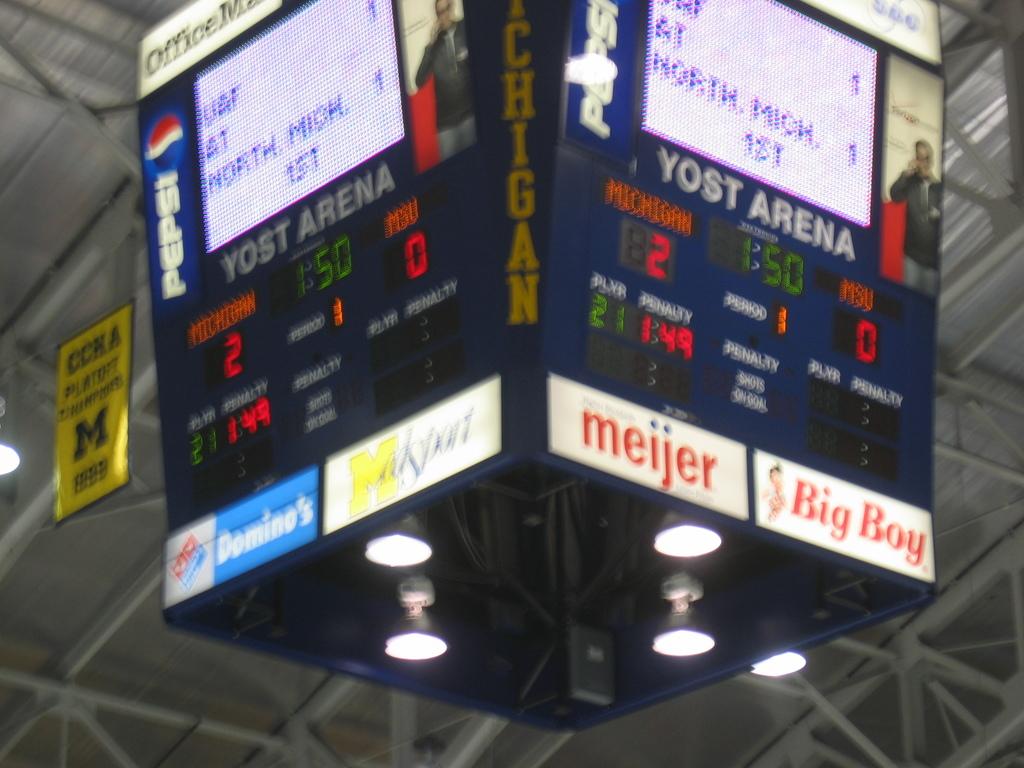What size, 'boy" does the sign say?
Your response must be concise. Big. What's the score?
Offer a terse response. 2-0. 